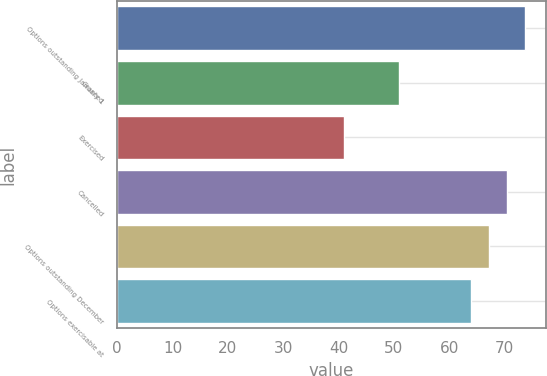Convert chart. <chart><loc_0><loc_0><loc_500><loc_500><bar_chart><fcel>Options outstanding January 1<fcel>Granted<fcel>Exercised<fcel>Cancelled<fcel>Options outstanding December<fcel>Options exercisable at<nl><fcel>73.75<fcel>50.86<fcel>40.98<fcel>70.51<fcel>67.27<fcel>64.03<nl></chart> 